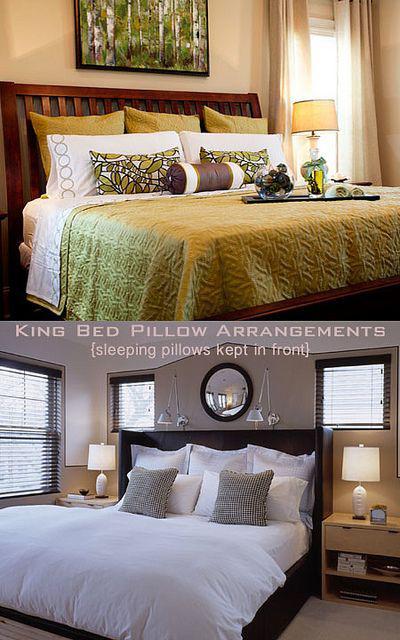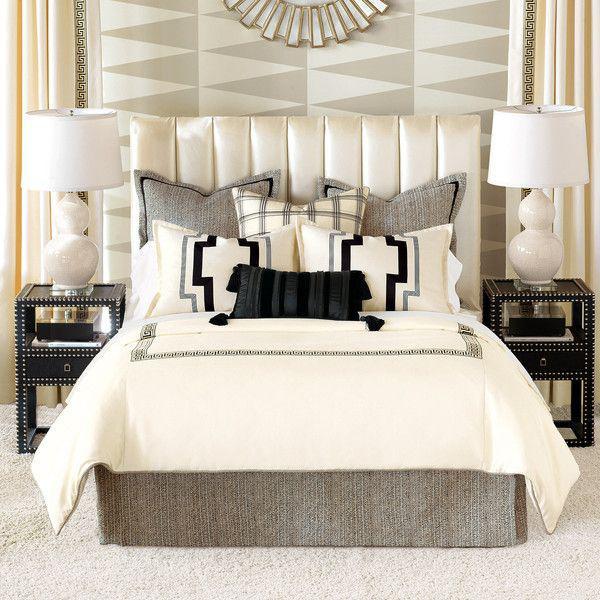The first image is the image on the left, the second image is the image on the right. Considering the images on both sides, is "both bedframes are brown" valid? Answer yes or no. No. 